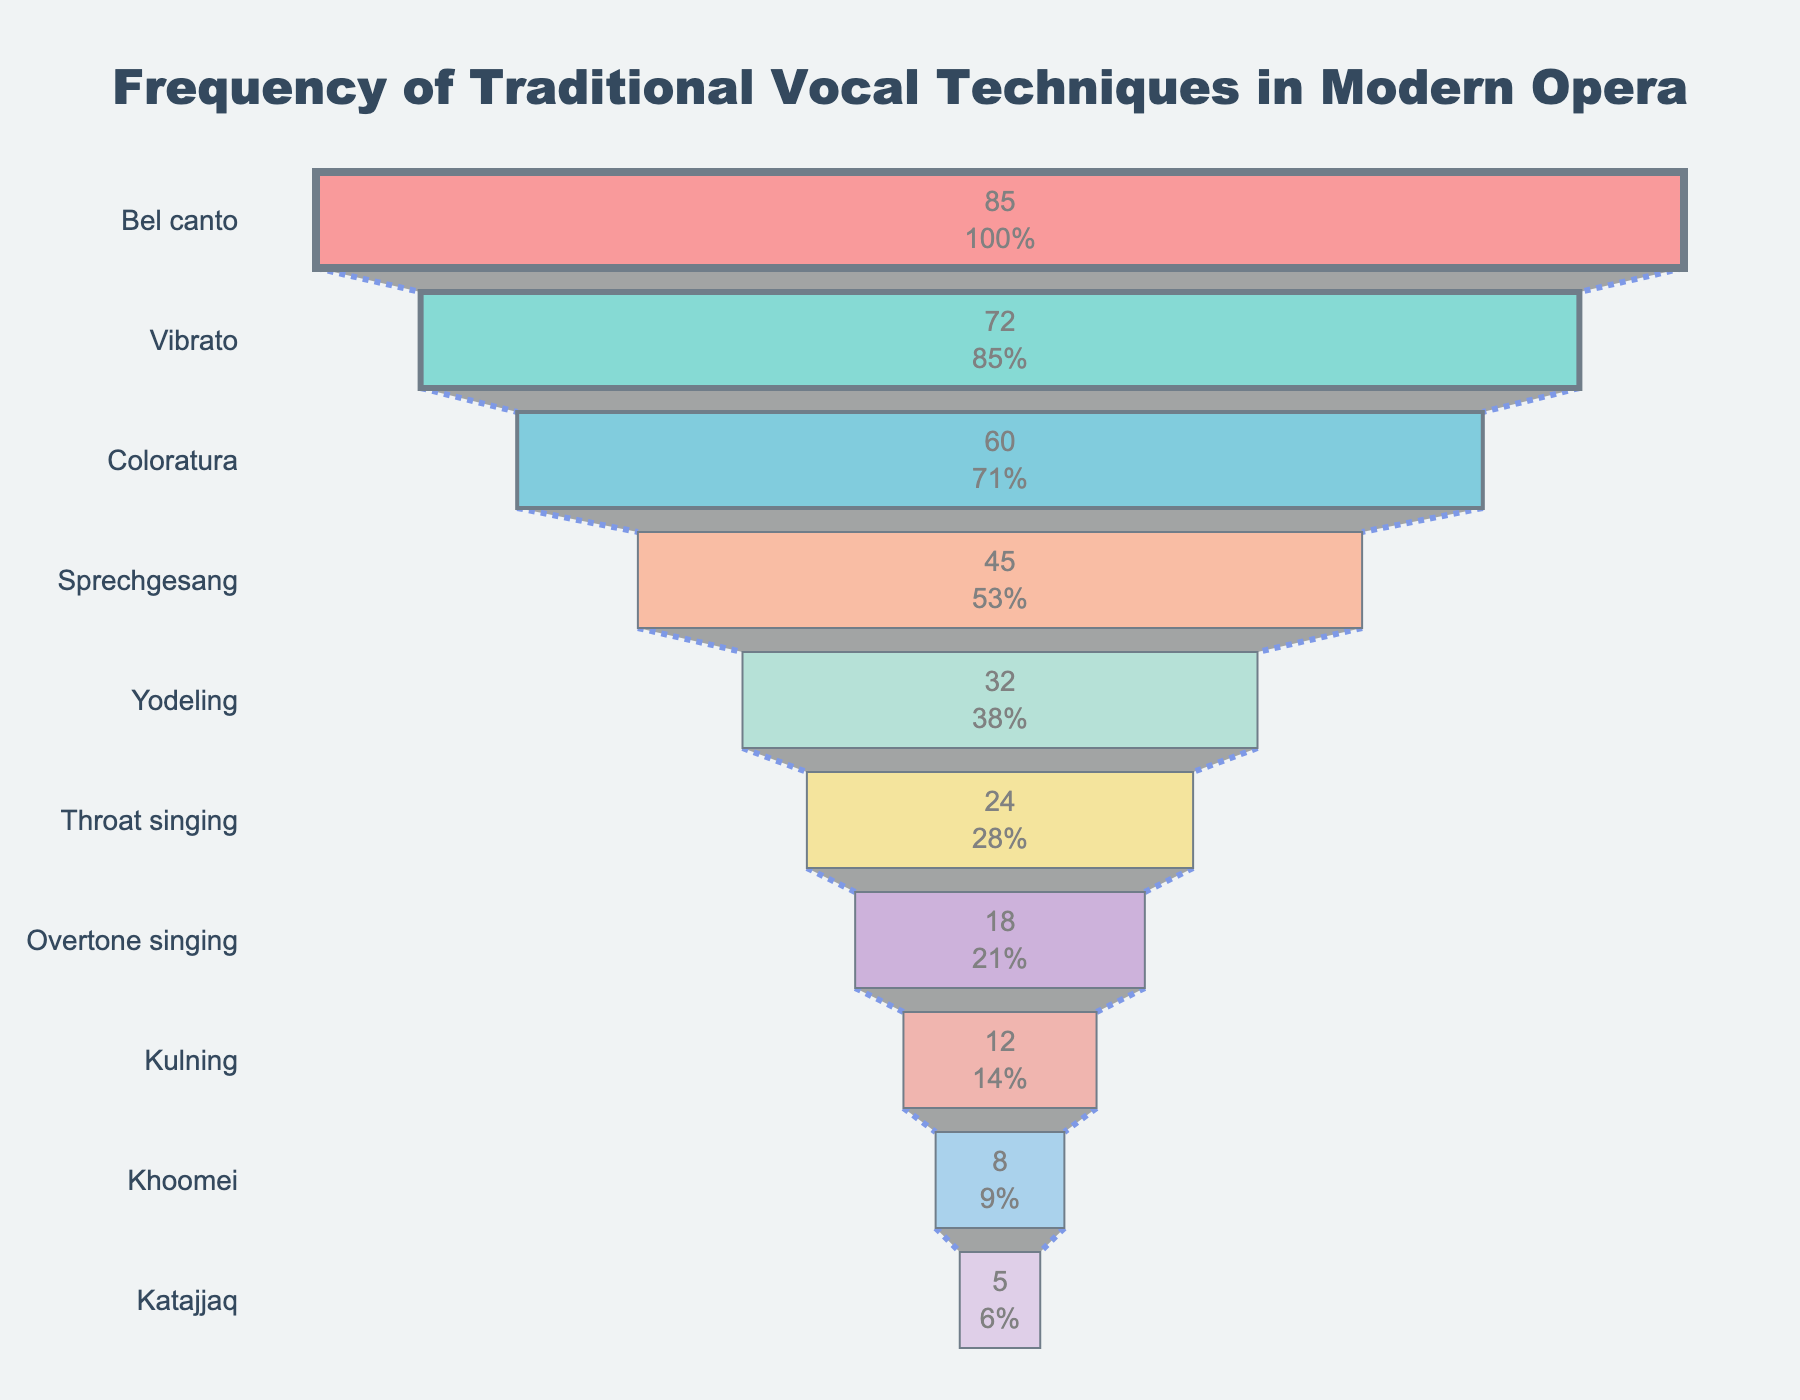What's the most frequently used traditional vocal technique in modern opera compositions? The most frequent technique is represented by the largest section at the top of the funnel chart. This section is labeled "Bel canto" with a frequency of 85.
Answer: Bel canto Which traditional vocal technique is used the least in modern opera compositions? The least frequently used technique is represented by the smallest section at the bottom of the funnel chart. This section is labeled "Katajjaq" with a frequency of 5.
Answer: Katajjaq How many techniques have a frequency greater than 50? Techniques with frequencies greater than 50 are positioned towards the top of the funnel chart. These are "Bel canto," "Vibrato," and "Coloratura," making a total of 3.
Answer: 3 What is the total frequency of all the traditional vocal techniques combined? Sum the frequencies of all techniques listed in the funnel chart: 85 + 72 + 60 + 45 + 32 + 24 + 18 + 12 + 8 + 5. This equals 361.
Answer: 361 How much more frequently is Bel canto used compared to Katajjaq? Subtract the frequency of Katajjaq from the frequency of Bel canto (85 - 5). The result is 80.
Answer: 80 Rank the top three vocal techniques from most to least common. The top three techniques are visible at the top of the funnel chart in decreasing order. They are "Bel canto" (85), "Vibrato" (72), and "Coloratura" (60).
Answer: Bel canto, Vibrato, Coloratura Which technique has a frequency just greater than Overtone singing? Overtone singing has a frequency of 18. By looking at the next larger section on the funnel chart, the technique is "Throat singing" with a frequency of 24.
Answer: Throat singing What's the percentage of modern opera compositions that include Vibrato, based on the total frequency? Divide the frequency of Vibrato by the total frequency and multiply by 100: (72 / 361) * 100 = approximately 19.94%.
Answer: 19.94% Are there more techniques with frequencies below or above 40? Count the number of techniques above and below 40:
Above 40: Bel canto, Vibrato, Coloratura, Sprechgesang (4 techniques).
Below 40: Yodeling, Throat singing, Overtone singing, Kulning, Khoomei, Katajjaq (6 techniques).
There are more techniques with frequencies below 40.
Answer: Below 40 What is the average frequency of the techniques used? Sum all frequencies and divide by the number of techniques: Total frequency is 361, and the number of techniques is 10. Therefore, 361 / 10 = 36.1.
Answer: 36.1 